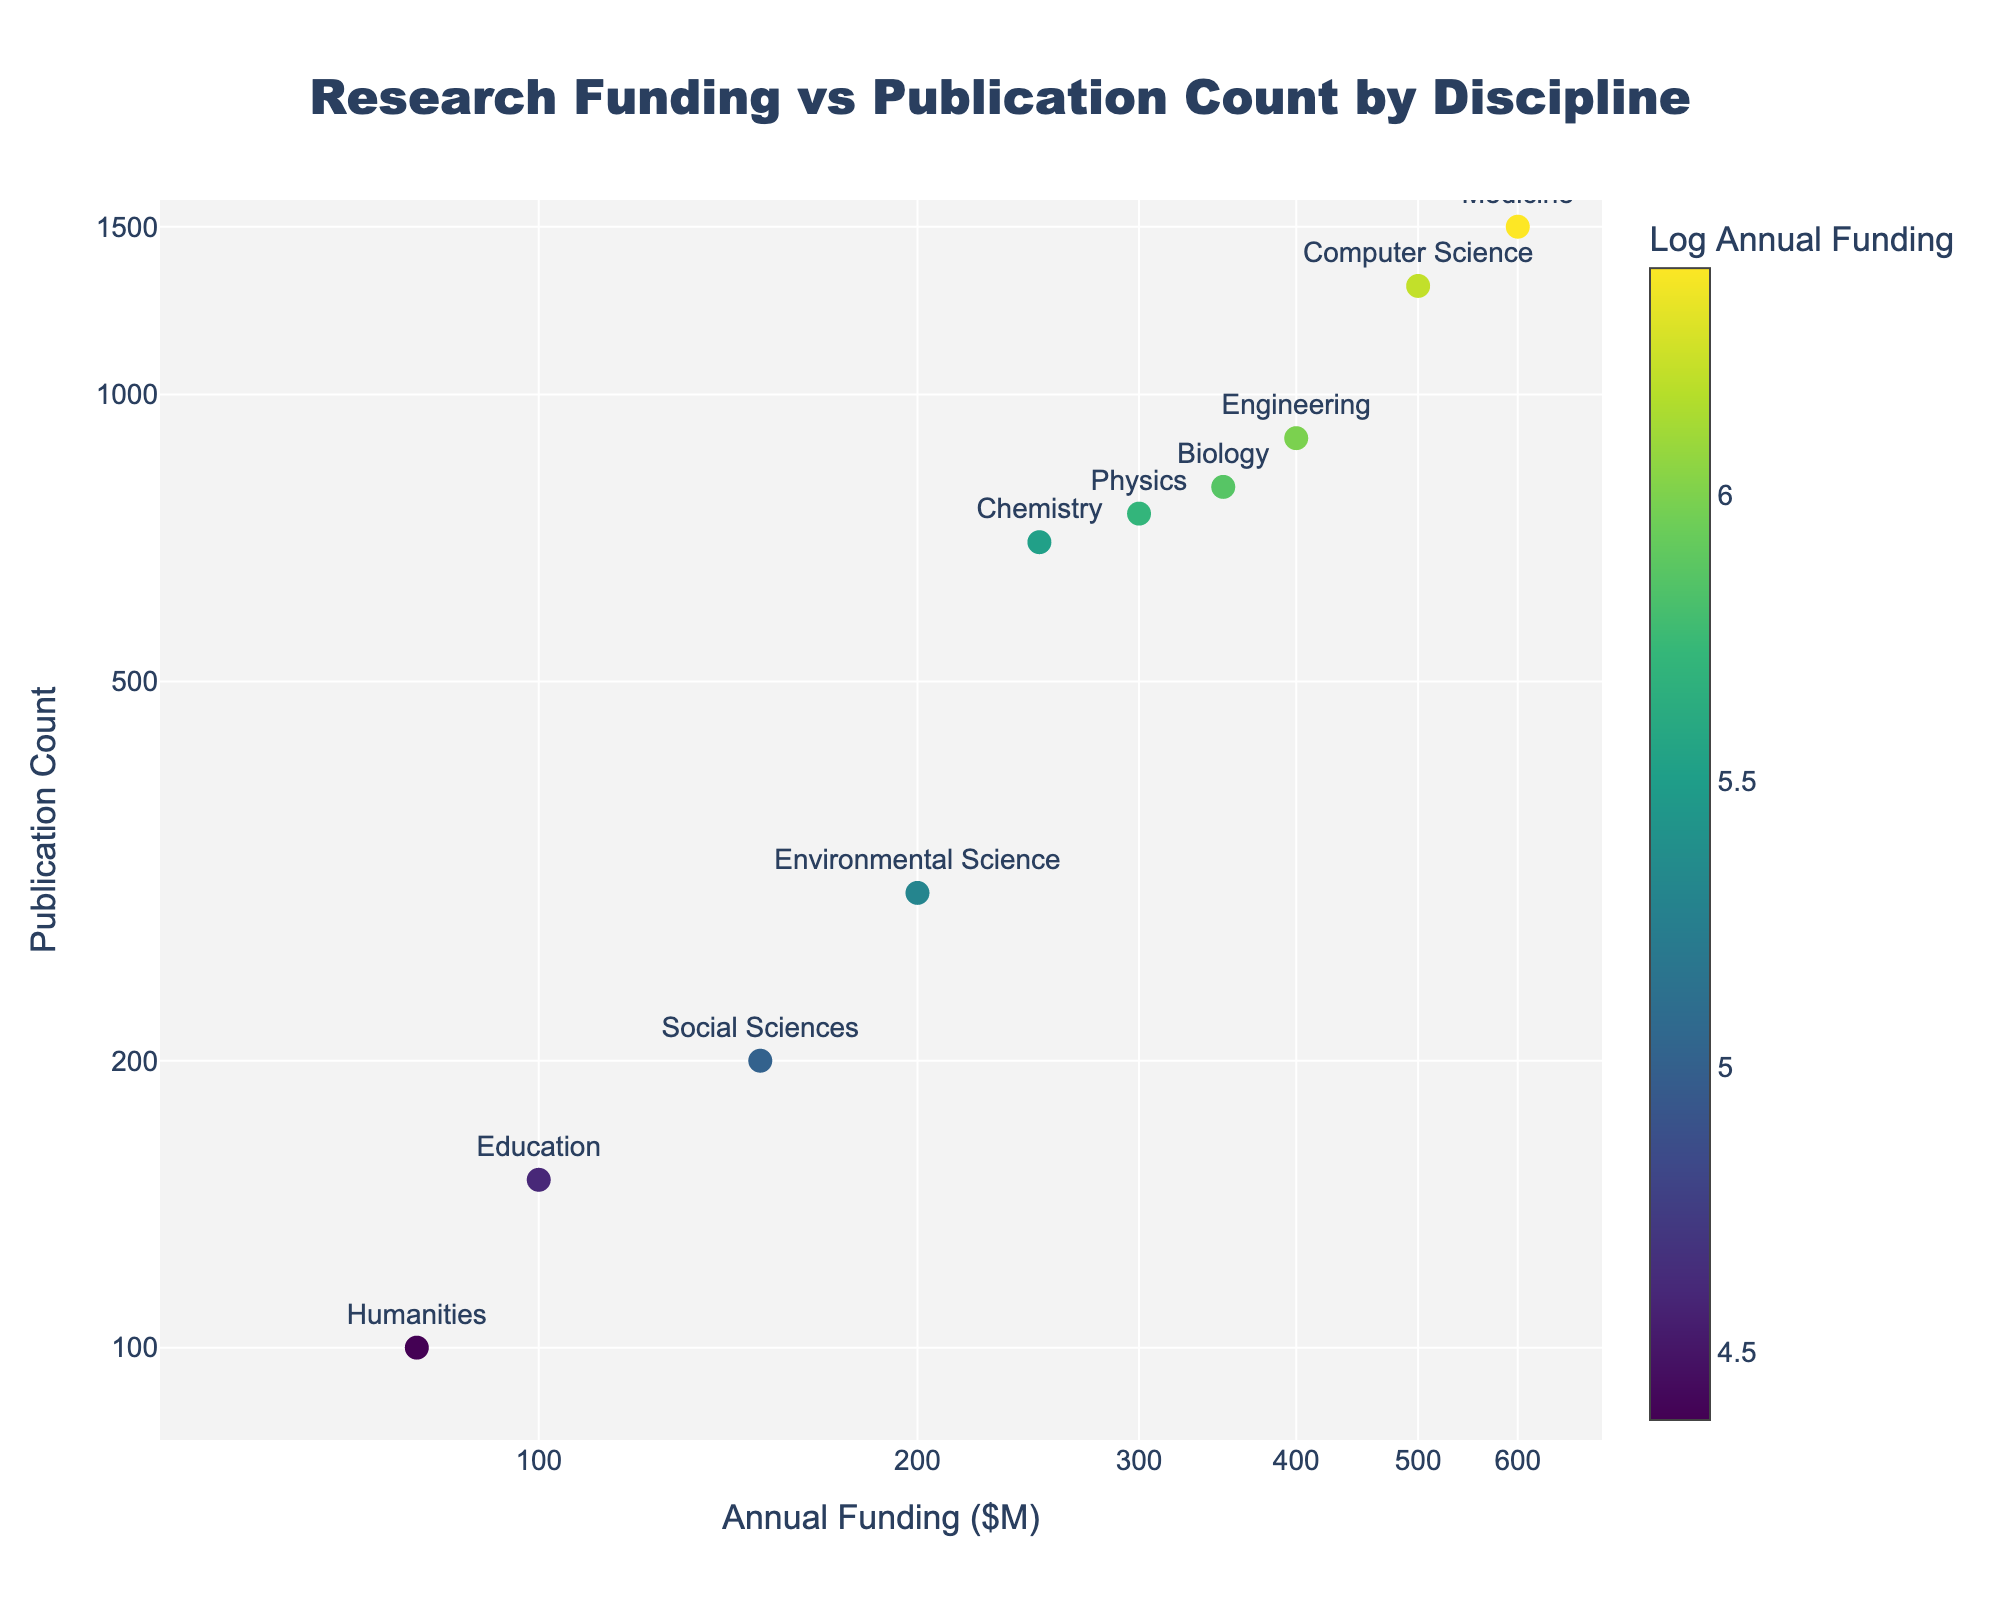How many disciplines are represented in the figure? The figure shows points labeled with different disciplines. Counting each distinct discipline from the labels will give the answer.
Answer: 10 Which discipline receives the highest annual funding? By looking at the x-axis (log scale) and identifying the point farthest to the right, we see that Medicine has the highest annual funding value.
Answer: Medicine What is the publication count for Computer Science? Locate the point labeled "Computer Science" and read its corresponding value on the y-axis (log scale).
Answer: 1300 Compare the annual funding for Engineering and Biology. Which is larger and by how much? Engineering's funding is 400M, and Biology's funding is 350M. 400M - 350M = 50M, so Engineering's funding is 50M larger.
Answer: Engineering, by 50M Which discipline has the lowest publication count? Identify the point on the plot that is the lowest on the y-axis (log scale), which is "Humanities" with 100 publications.
Answer: Humanities What is the range of annual funding values shown on the plot? The x-axis shows values from a minimum of about 80M to a maximum of 600M on a log scale.
Answer: 80M to 600M How does the publication count for Social Sciences compare to that of Environmental Science? Social Sciences has 200 publications, while Environmental Science has 300 publications. 200 < 300.
Answer: Environmental Science is larger by 100 What is the median annual funding across all disciplines? To find the median, sort the funding values (80, 100, 150, 200, 250, 300, 350, 400, 500, 600) and find the middle value. Median is (250 + 300) / 2 = 275M.
Answer: 275M Which disciplines fall above the median value of publication count (800)? Identify the disciplines with publication counts above 800. They include Engineering (900), Medicine (1500), Computer Science (1300).
Answer: Engineering, Medicine, Computer Science 